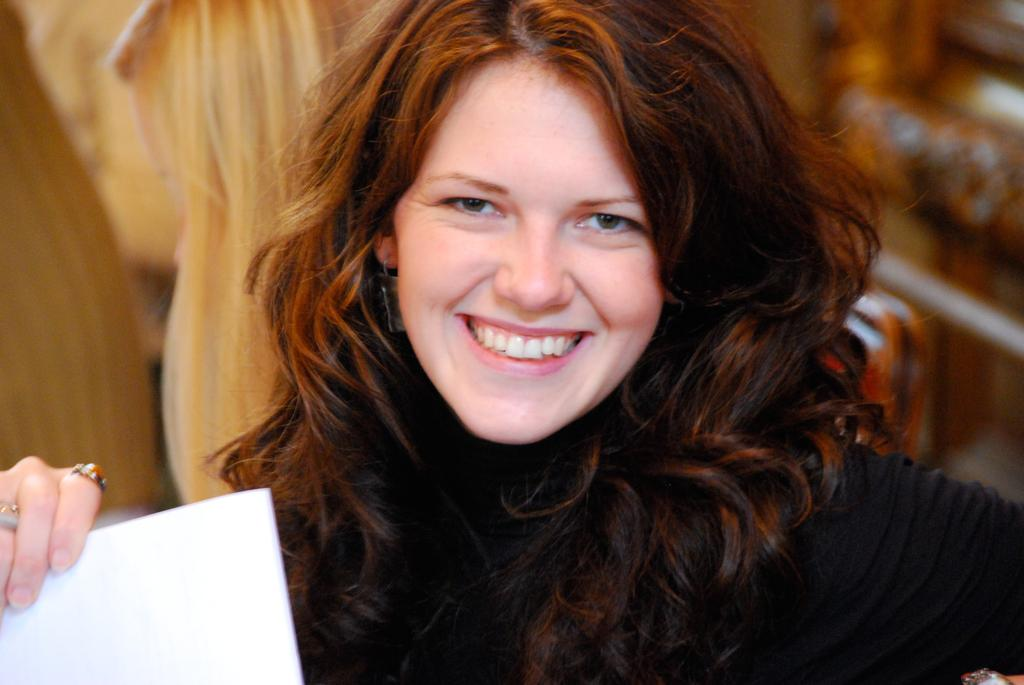What is the main subject of the image? There is a person in the image. What is the person doing in the image? The person is holding an object. Can you describe the background of the image? The background of the image is blurred. What type of garden can be seen in the background of the image? There is no garden visible in the image; the background is blurred. What kind of steel is used to make the jeans worn by the person in the image? There is no mention of jeans in the image, and the person's clothing is not described. 